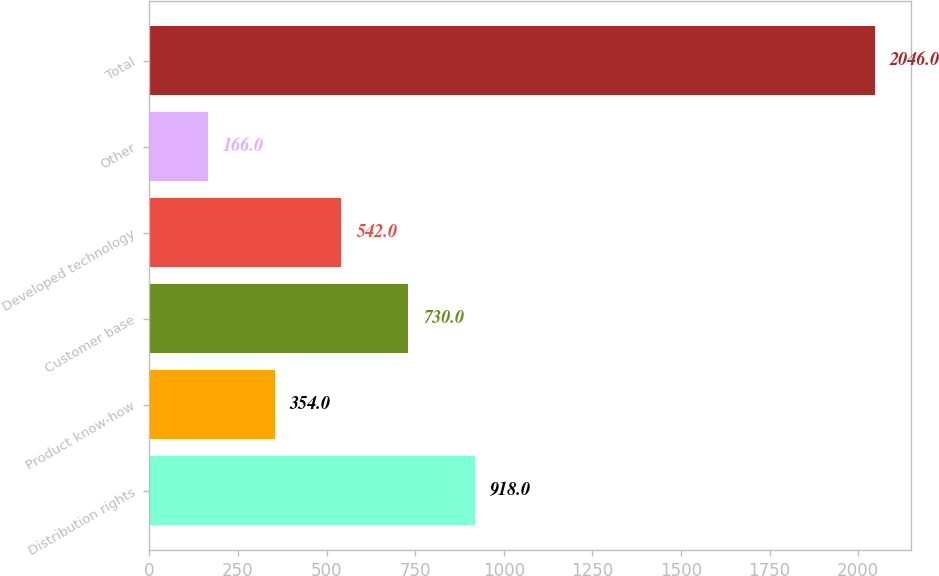Convert chart. <chart><loc_0><loc_0><loc_500><loc_500><bar_chart><fcel>Distribution rights<fcel>Product know-how<fcel>Customer base<fcel>Developed technology<fcel>Other<fcel>Total<nl><fcel>918<fcel>354<fcel>730<fcel>542<fcel>166<fcel>2046<nl></chart> 